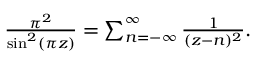Convert formula to latex. <formula><loc_0><loc_0><loc_500><loc_500>\begin{array} { r } { { \frac { \pi ^ { 2 } } { \sin ^ { 2 } ( \pi z ) } } = \sum _ { n = - \infty } ^ { \infty } { \frac { 1 } { ( z - n ) ^ { 2 } } } . } \end{array}</formula> 